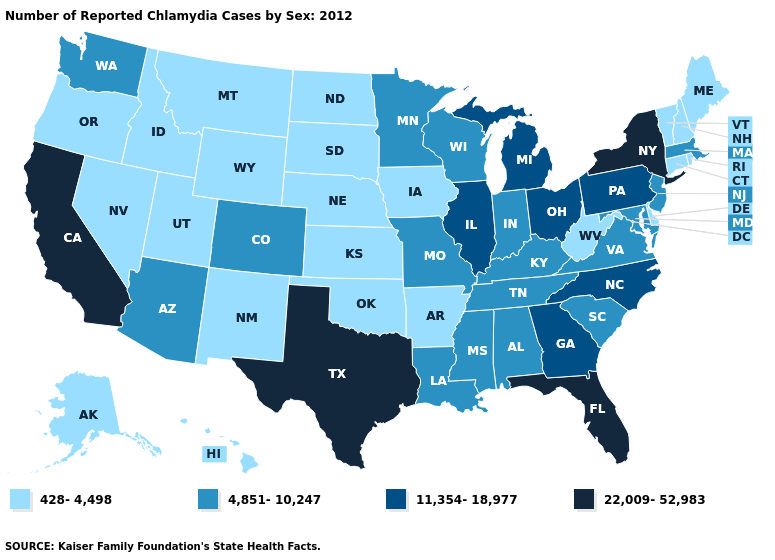Does Louisiana have a higher value than Wisconsin?
Quick response, please. No. Which states have the lowest value in the South?
Give a very brief answer. Arkansas, Delaware, Oklahoma, West Virginia. Name the states that have a value in the range 4,851-10,247?
Quick response, please. Alabama, Arizona, Colorado, Indiana, Kentucky, Louisiana, Maryland, Massachusetts, Minnesota, Mississippi, Missouri, New Jersey, South Carolina, Tennessee, Virginia, Washington, Wisconsin. Which states hav the highest value in the West?
Give a very brief answer. California. Among the states that border Colorado , does Arizona have the lowest value?
Quick response, please. No. Name the states that have a value in the range 4,851-10,247?
Keep it brief. Alabama, Arizona, Colorado, Indiana, Kentucky, Louisiana, Maryland, Massachusetts, Minnesota, Mississippi, Missouri, New Jersey, South Carolina, Tennessee, Virginia, Washington, Wisconsin. Name the states that have a value in the range 11,354-18,977?
Write a very short answer. Georgia, Illinois, Michigan, North Carolina, Ohio, Pennsylvania. What is the lowest value in states that border Oregon?
Give a very brief answer. 428-4,498. Does the first symbol in the legend represent the smallest category?
Keep it brief. Yes. What is the value of Oklahoma?
Be succinct. 428-4,498. Does Alaska have the highest value in the West?
Be succinct. No. What is the lowest value in states that border Oklahoma?
Concise answer only. 428-4,498. What is the value of Montana?
Write a very short answer. 428-4,498. What is the highest value in states that border Maryland?
Answer briefly. 11,354-18,977. Is the legend a continuous bar?
Keep it brief. No. 